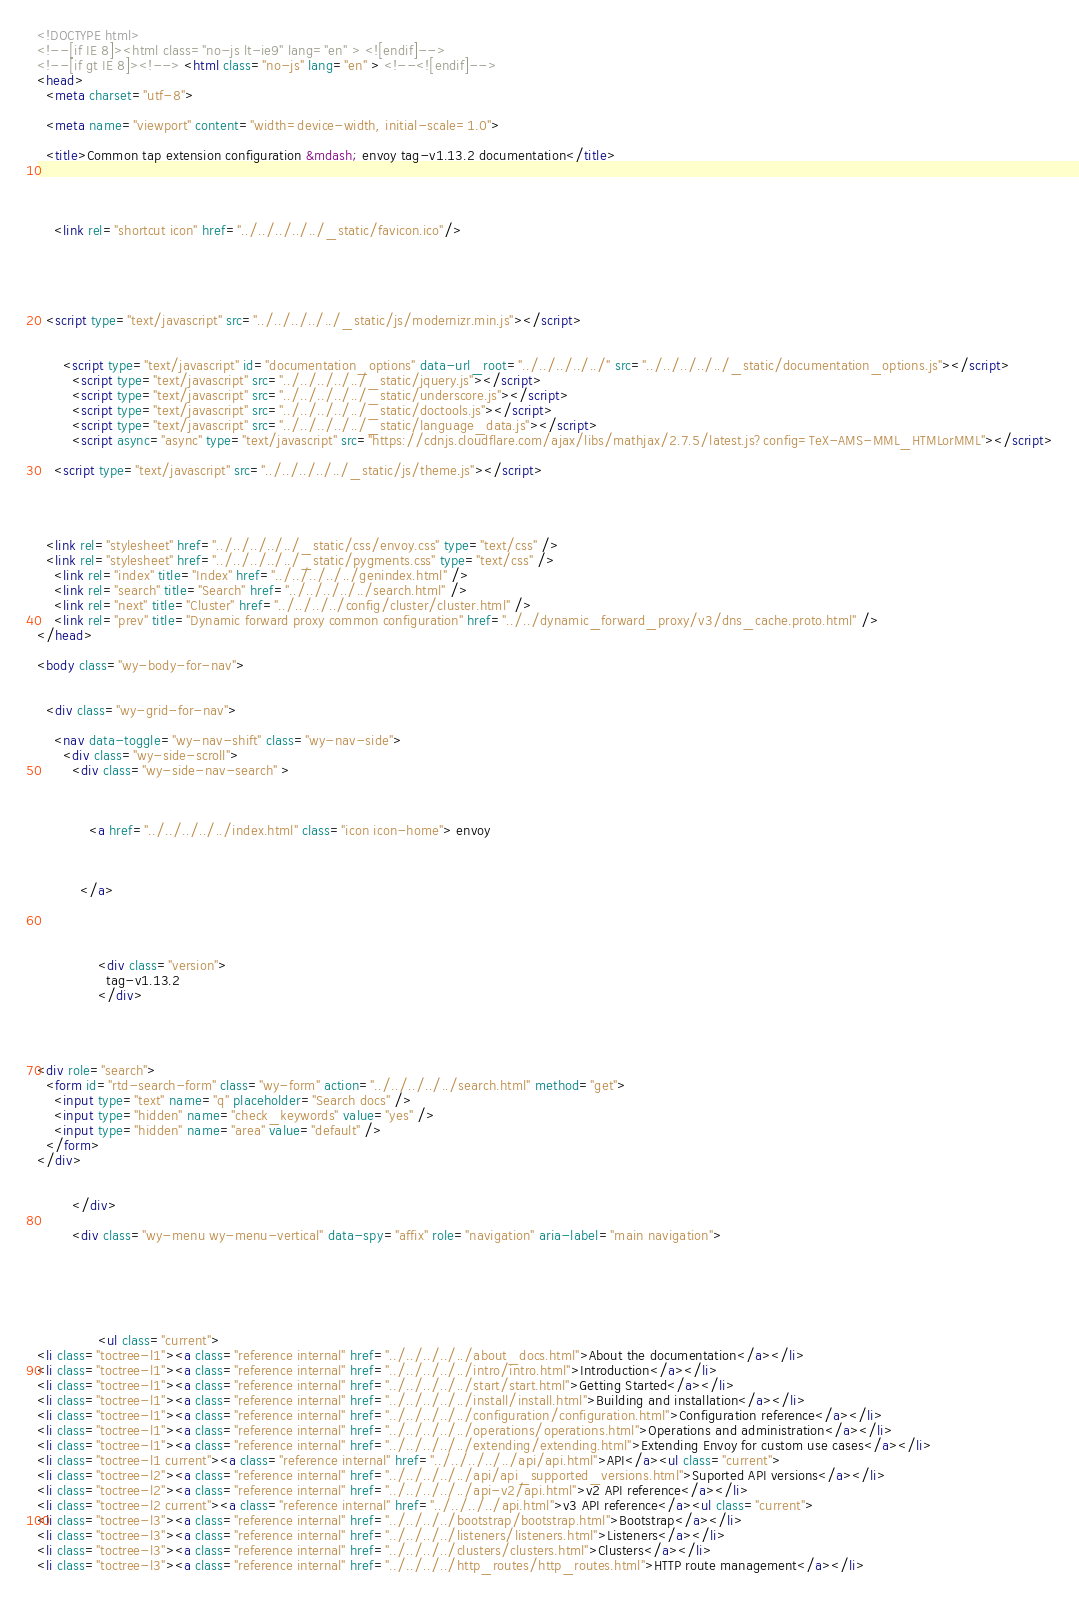Convert code to text. <code><loc_0><loc_0><loc_500><loc_500><_HTML_>

<!DOCTYPE html>
<!--[if IE 8]><html class="no-js lt-ie9" lang="en" > <![endif]-->
<!--[if gt IE 8]><!--> <html class="no-js" lang="en" > <!--<![endif]-->
<head>
  <meta charset="utf-8">
  
  <meta name="viewport" content="width=device-width, initial-scale=1.0">
  
  <title>Common tap extension configuration &mdash; envoy tag-v1.13.2 documentation</title>
  

  
  
    <link rel="shortcut icon" href="../../../../../_static/favicon.ico"/>
  
  
  

  
  <script type="text/javascript" src="../../../../../_static/js/modernizr.min.js"></script>
  
    
      <script type="text/javascript" id="documentation_options" data-url_root="../../../../../" src="../../../../../_static/documentation_options.js"></script>
        <script type="text/javascript" src="../../../../../_static/jquery.js"></script>
        <script type="text/javascript" src="../../../../../_static/underscore.js"></script>
        <script type="text/javascript" src="../../../../../_static/doctools.js"></script>
        <script type="text/javascript" src="../../../../../_static/language_data.js"></script>
        <script async="async" type="text/javascript" src="https://cdnjs.cloudflare.com/ajax/libs/mathjax/2.7.5/latest.js?config=TeX-AMS-MML_HTMLorMML"></script>
    
    <script type="text/javascript" src="../../../../../_static/js/theme.js"></script>

    

  
  <link rel="stylesheet" href="../../../../../_static/css/envoy.css" type="text/css" />
  <link rel="stylesheet" href="../../../../../_static/pygments.css" type="text/css" />
    <link rel="index" title="Index" href="../../../../../genindex.html" />
    <link rel="search" title="Search" href="../../../../../search.html" />
    <link rel="next" title="Cluster" href="../../../../config/cluster/cluster.html" />
    <link rel="prev" title="Dynamic forward proxy common configuration" href="../../dynamic_forward_proxy/v3/dns_cache.proto.html" /> 
</head>

<body class="wy-body-for-nav">

   
  <div class="wy-grid-for-nav">
    
    <nav data-toggle="wy-nav-shift" class="wy-nav-side">
      <div class="wy-side-scroll">
        <div class="wy-side-nav-search" >
          

          
            <a href="../../../../../index.html" class="icon icon-home"> envoy
          

          
          </a>

          
            
            
              <div class="version">
                tag-v1.13.2
              </div>
            
          

          
<div role="search">
  <form id="rtd-search-form" class="wy-form" action="../../../../../search.html" method="get">
    <input type="text" name="q" placeholder="Search docs" />
    <input type="hidden" name="check_keywords" value="yes" />
    <input type="hidden" name="area" value="default" />
  </form>
</div>

          
        </div>

        <div class="wy-menu wy-menu-vertical" data-spy="affix" role="navigation" aria-label="main navigation">
          
            
            
              
            
            
              <ul class="current">
<li class="toctree-l1"><a class="reference internal" href="../../../../../about_docs.html">About the documentation</a></li>
<li class="toctree-l1"><a class="reference internal" href="../../../../../intro/intro.html">Introduction</a></li>
<li class="toctree-l1"><a class="reference internal" href="../../../../../start/start.html">Getting Started</a></li>
<li class="toctree-l1"><a class="reference internal" href="../../../../../install/install.html">Building and installation</a></li>
<li class="toctree-l1"><a class="reference internal" href="../../../../../configuration/configuration.html">Configuration reference</a></li>
<li class="toctree-l1"><a class="reference internal" href="../../../../../operations/operations.html">Operations and administration</a></li>
<li class="toctree-l1"><a class="reference internal" href="../../../../../extending/extending.html">Extending Envoy for custom use cases</a></li>
<li class="toctree-l1 current"><a class="reference internal" href="../../../../../api/api.html">API</a><ul class="current">
<li class="toctree-l2"><a class="reference internal" href="../../../../../api/api_supported_versions.html">Suported API versions</a></li>
<li class="toctree-l2"><a class="reference internal" href="../../../../../api-v2/api.html">v2 API reference</a></li>
<li class="toctree-l2 current"><a class="reference internal" href="../../../../api.html">v3 API reference</a><ul class="current">
<li class="toctree-l3"><a class="reference internal" href="../../../../bootstrap/bootstrap.html">Bootstrap</a></li>
<li class="toctree-l3"><a class="reference internal" href="../../../../listeners/listeners.html">Listeners</a></li>
<li class="toctree-l3"><a class="reference internal" href="../../../../clusters/clusters.html">Clusters</a></li>
<li class="toctree-l3"><a class="reference internal" href="../../../../http_routes/http_routes.html">HTTP route management</a></li></code> 